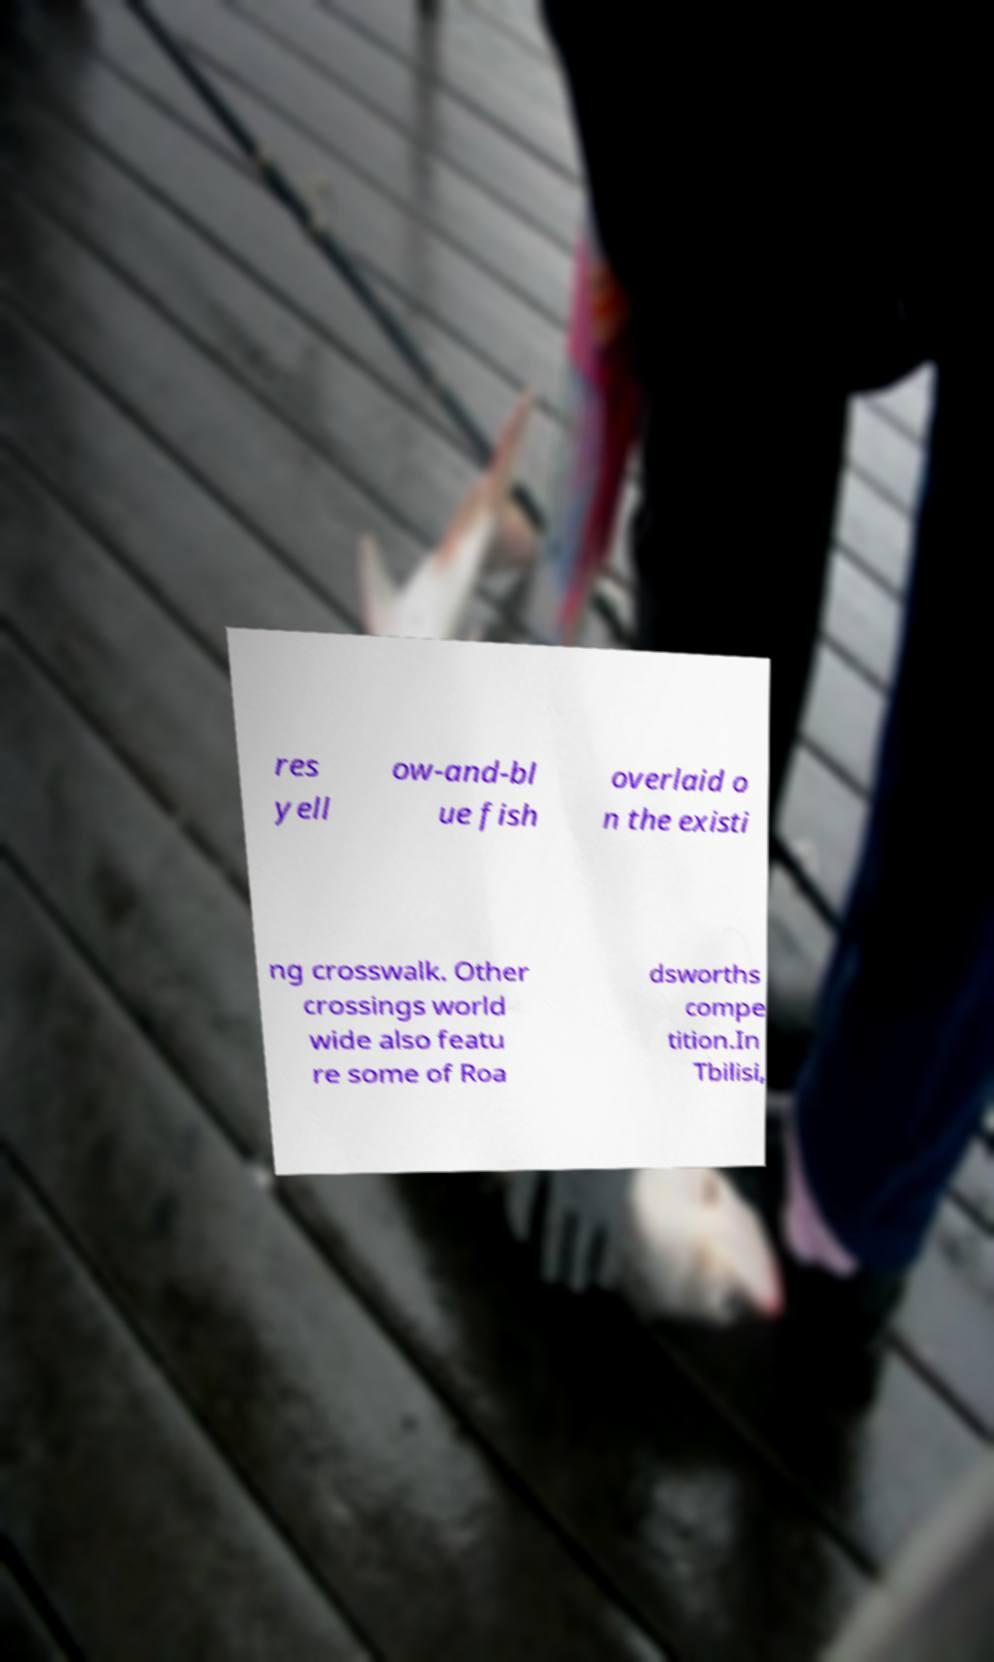Could you extract and type out the text from this image? res yell ow-and-bl ue fish overlaid o n the existi ng crosswalk. Other crossings world wide also featu re some of Roa dsworths compe tition.In Tbilisi, 